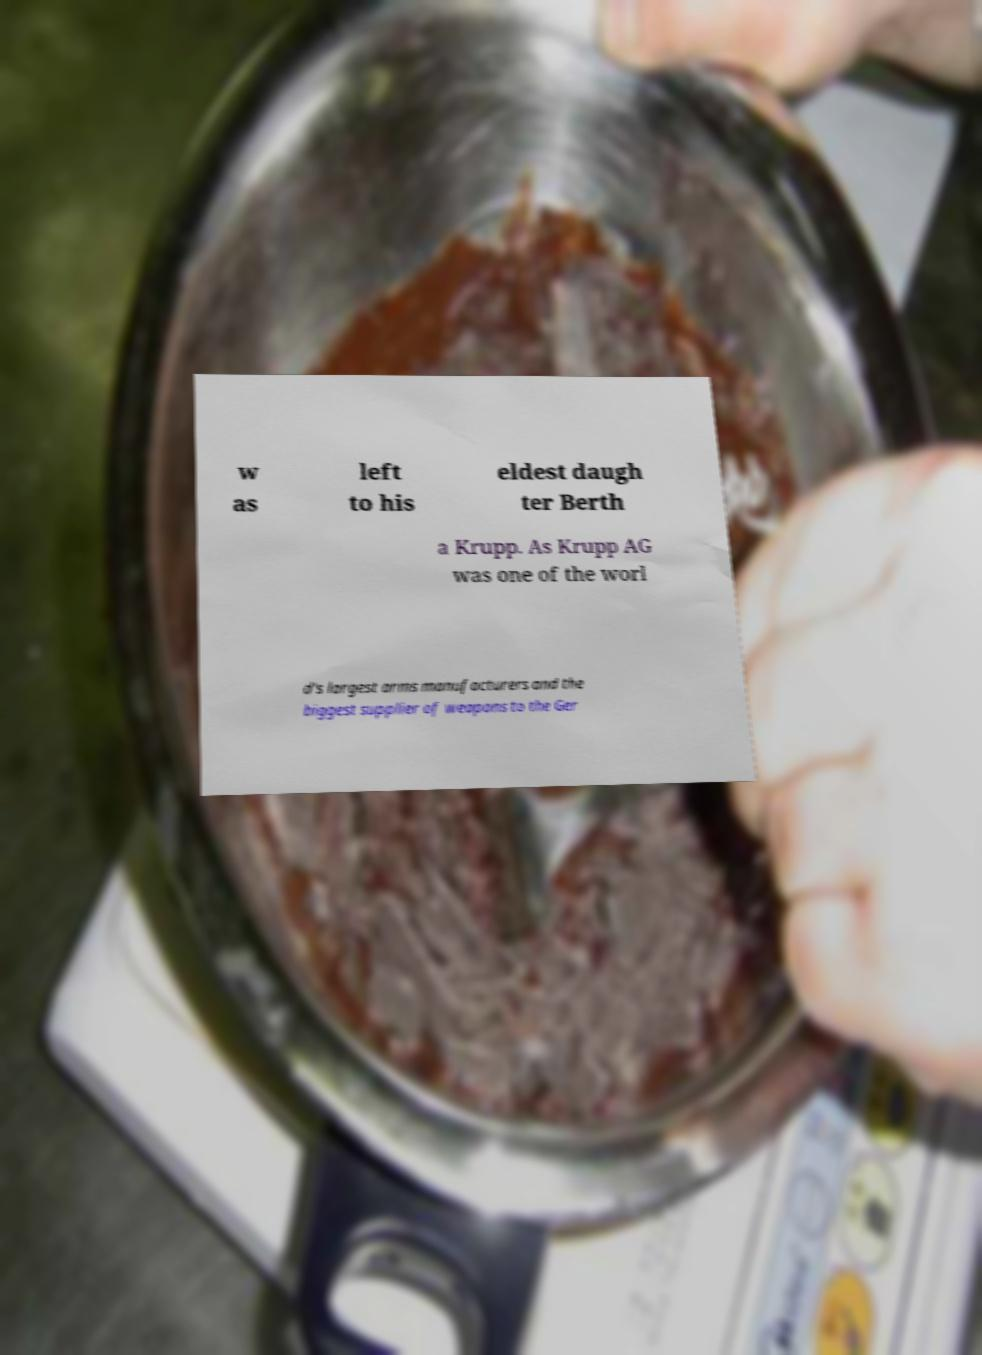Can you accurately transcribe the text from the provided image for me? w as left to his eldest daugh ter Berth a Krupp. As Krupp AG was one of the worl d's largest arms manufacturers and the biggest supplier of weapons to the Ger 